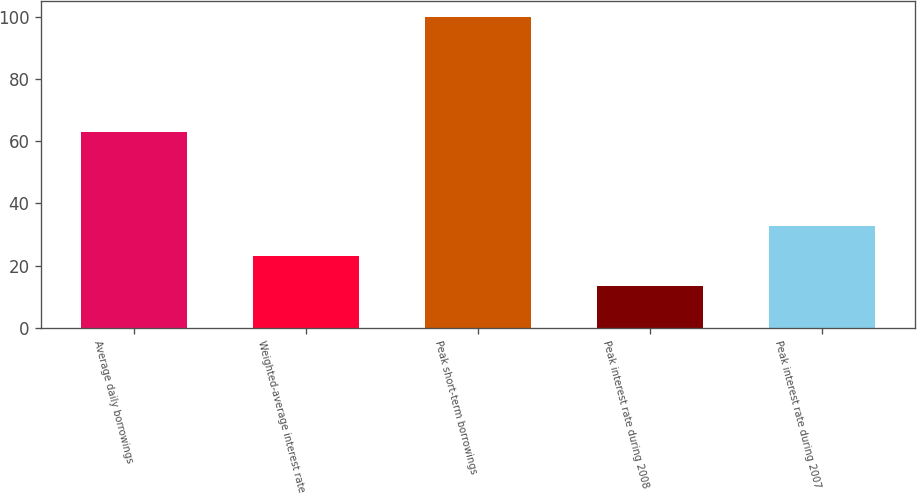<chart> <loc_0><loc_0><loc_500><loc_500><bar_chart><fcel>Average daily borrowings<fcel>Weighted-average interest rate<fcel>Peak short-term borrowings<fcel>Peak interest rate during 2008<fcel>Peak interest rate during 2007<nl><fcel>63<fcel>23.02<fcel>100<fcel>13.4<fcel>32.64<nl></chart> 